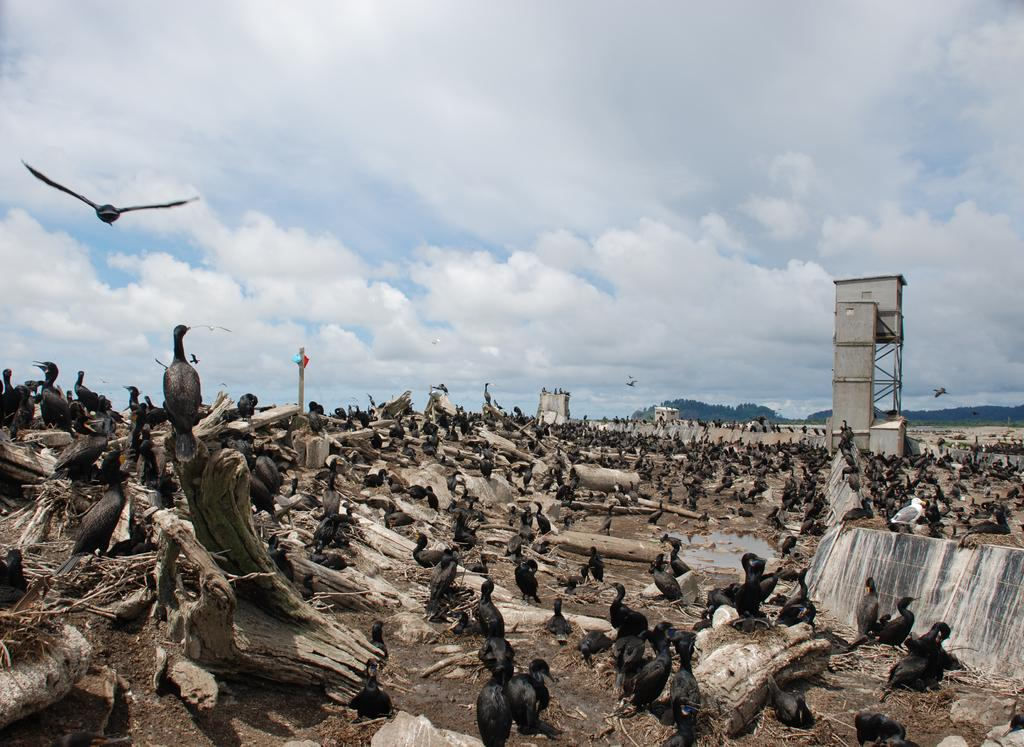What objects can be seen in the image? There are logs and birds in the image. What structure is visible in the background of the image? There is a tower in the background of the image. What other object can be seen in the image? There is a pole in the image. What type of natural landscape is visible in the background of the image? There are hills in the background of the image. What is visible at the top of the image? The sky is visible at the top of the image. Where is the cobweb located in the image? There is no cobweb present in the image. What type of metal is used to construct the oven in the image? There is no oven present in the image. 